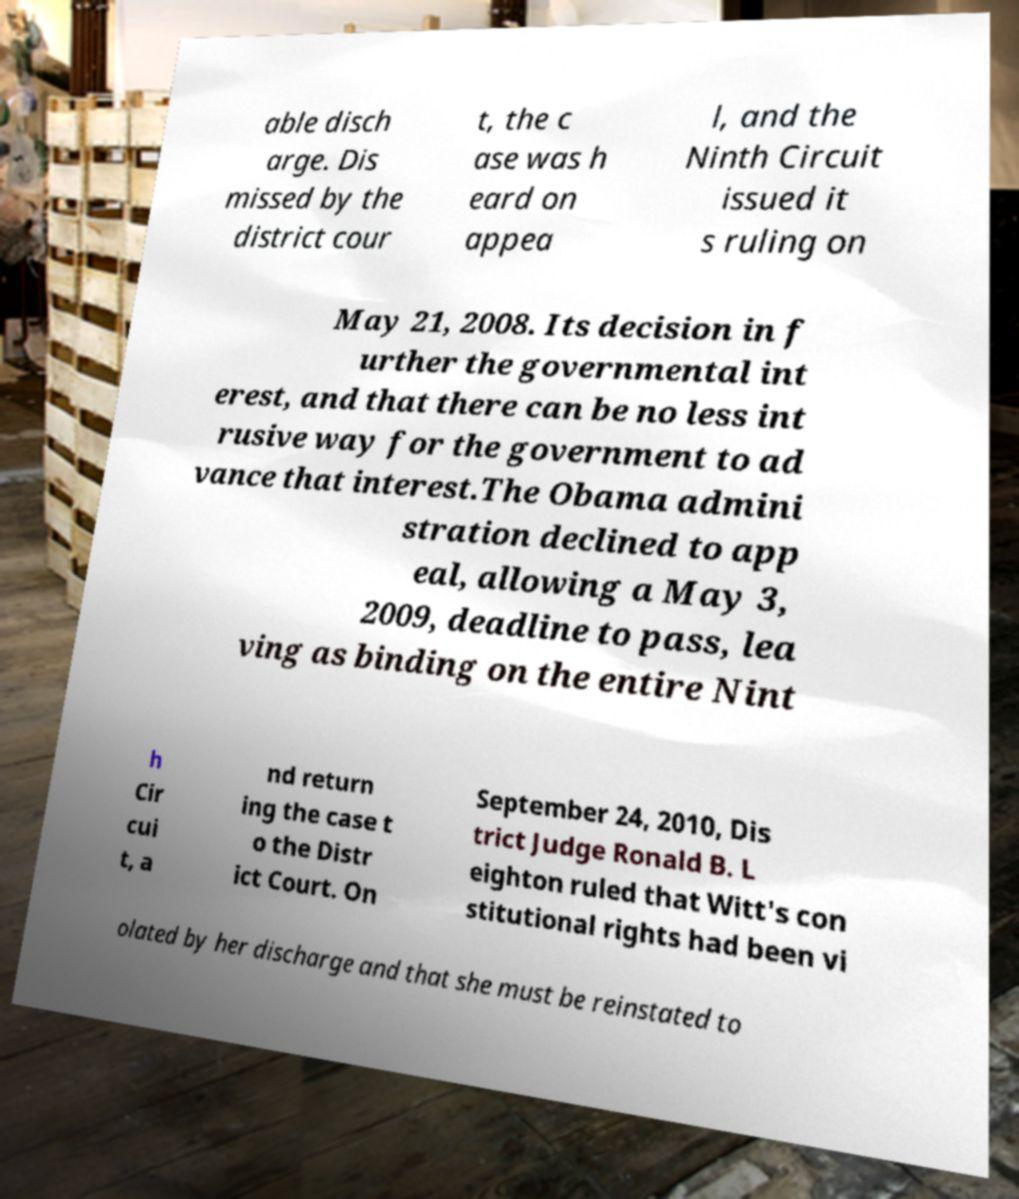For documentation purposes, I need the text within this image transcribed. Could you provide that? able disch arge. Dis missed by the district cour t, the c ase was h eard on appea l, and the Ninth Circuit issued it s ruling on May 21, 2008. Its decision in f urther the governmental int erest, and that there can be no less int rusive way for the government to ad vance that interest.The Obama admini stration declined to app eal, allowing a May 3, 2009, deadline to pass, lea ving as binding on the entire Nint h Cir cui t, a nd return ing the case t o the Distr ict Court. On September 24, 2010, Dis trict Judge Ronald B. L eighton ruled that Witt's con stitutional rights had been vi olated by her discharge and that she must be reinstated to 